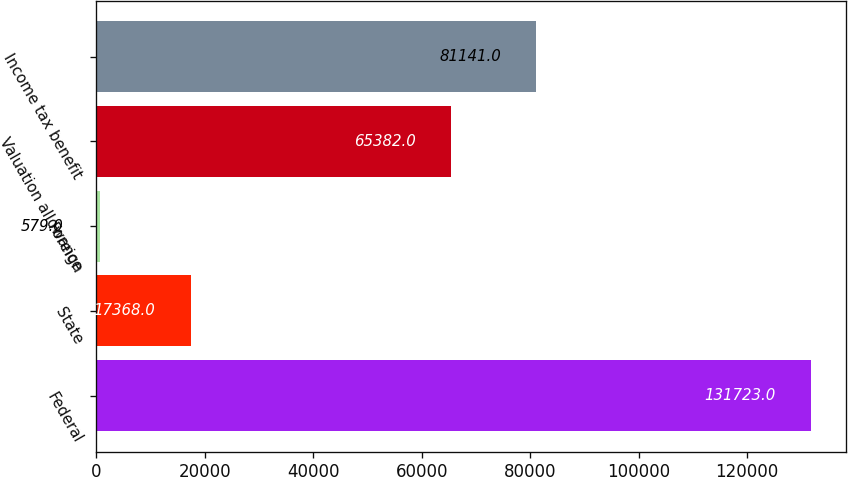Convert chart to OTSL. <chart><loc_0><loc_0><loc_500><loc_500><bar_chart><fcel>Federal<fcel>State<fcel>Foreign<fcel>Valuation allowance<fcel>Income tax benefit<nl><fcel>131723<fcel>17368<fcel>579<fcel>65382<fcel>81141<nl></chart> 